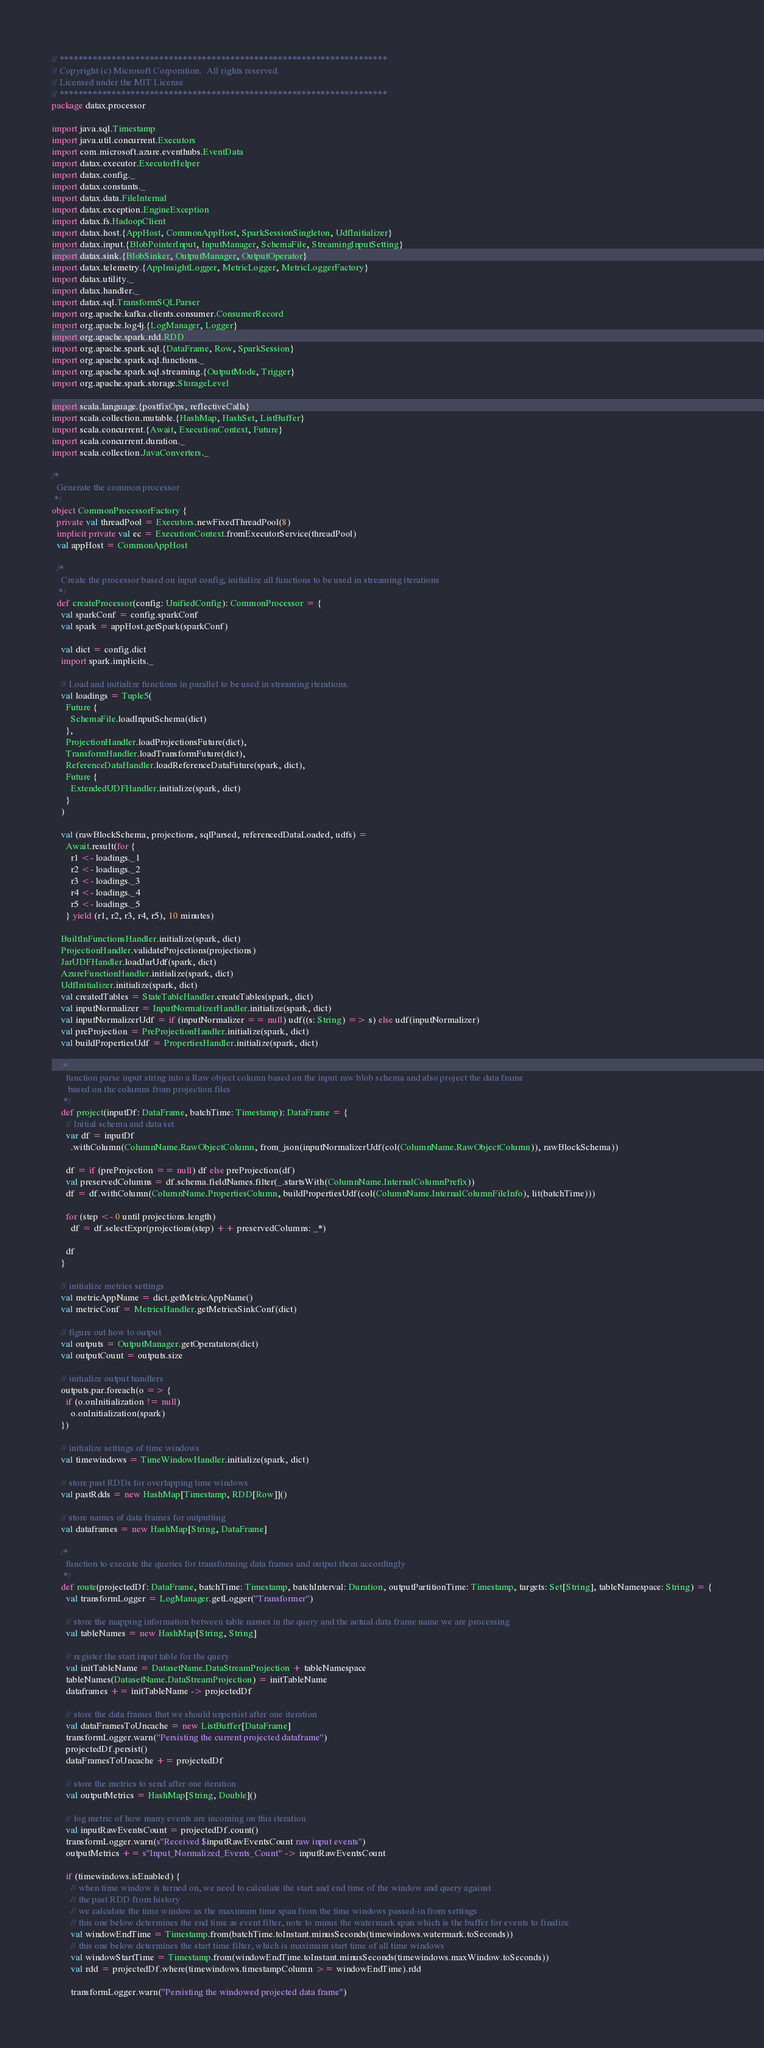Convert code to text. <code><loc_0><loc_0><loc_500><loc_500><_Scala_>// *********************************************************************
// Copyright (c) Microsoft Corporation.  All rights reserved.
// Licensed under the MIT License
// *********************************************************************
package datax.processor

import java.sql.Timestamp
import java.util.concurrent.Executors
import com.microsoft.azure.eventhubs.EventData
import datax.executor.ExecutorHelper
import datax.config._
import datax.constants._
import datax.data.FileInternal
import datax.exception.EngineException
import datax.fs.HadoopClient
import datax.host.{AppHost, CommonAppHost, SparkSessionSingleton, UdfInitializer}
import datax.input.{BlobPointerInput, InputManager, SchemaFile, StreamingInputSetting}
import datax.sink.{BlobSinker, OutputManager, OutputOperator}
import datax.telemetry.{AppInsightLogger, MetricLogger, MetricLoggerFactory}
import datax.utility._
import datax.handler._
import datax.sql.TransformSQLParser
import org.apache.kafka.clients.consumer.ConsumerRecord
import org.apache.log4j.{LogManager, Logger}
import org.apache.spark.rdd.RDD
import org.apache.spark.sql.{DataFrame, Row, SparkSession}
import org.apache.spark.sql.functions._
import org.apache.spark.sql.streaming.{OutputMode, Trigger}
import org.apache.spark.storage.StorageLevel

import scala.language.{postfixOps, reflectiveCalls}
import scala.collection.mutable.{HashMap, HashSet, ListBuffer}
import scala.concurrent.{Await, ExecutionContext, Future}
import scala.concurrent.duration._
import scala.collection.JavaConverters._

/*
  Generate the common processor
 */
object CommonProcessorFactory {
  private val threadPool = Executors.newFixedThreadPool(8)
  implicit private val ec = ExecutionContext.fromExecutorService(threadPool)
  val appHost = CommonAppHost

  /*
    Create the processor based on input config, initialize all functions to be used in streaming iterations
   */
  def createProcessor(config: UnifiedConfig): CommonProcessor = {
    val sparkConf = config.sparkConf
    val spark = appHost.getSpark(sparkConf)

    val dict = config.dict
    import spark.implicits._

    // Load and initialize functions in parallel to be used in streaming iterations.
    val loadings = Tuple5(
      Future {
        SchemaFile.loadInputSchema(dict)
      },
      ProjectionHandler.loadProjectionsFuture(dict),
      TransformHandler.loadTransformFuture(dict),
      ReferenceDataHandler.loadReferenceDataFuture(spark, dict),
      Future {
        ExtendedUDFHandler.initialize(spark, dict)
      }
    )

    val (rawBlockSchema, projections, sqlParsed, referencedDataLoaded, udfs) =
      Await.result(for {
        r1 <- loadings._1
        r2 <- loadings._2
        r3 <- loadings._3
        r4 <- loadings._4
        r5 <- loadings._5
      } yield (r1, r2, r3, r4, r5), 10 minutes)

    BuiltInFunctionsHandler.initialize(spark, dict)
    ProjectionHandler.validateProjections(projections)
    JarUDFHandler.loadJarUdf(spark, dict)
    AzureFunctionHandler.initialize(spark, dict)
    UdfInitializer.initialize(spark, dict)
    val createdTables = StateTableHandler.createTables(spark, dict)
    val inputNormalizer = InputNormalizerHandler.initialize(spark, dict)
    val inputNormalizerUdf = if (inputNormalizer == null) udf((s: String) => s) else udf(inputNormalizer)
    val preProjection = PreProjectionHandler.initialize(spark, dict)
    val buildPropertiesUdf = PropertiesHandler.initialize(spark, dict)

    /*
      function parse input string into a Raw object column based on the input raw blob schema and also project the data frame
       based on the columns from projection files
     */
    def project(inputDf: DataFrame, batchTime: Timestamp): DataFrame = {
      // Initial schema and data set
      var df = inputDf
        .withColumn(ColumnName.RawObjectColumn, from_json(inputNormalizerUdf(col(ColumnName.RawObjectColumn)), rawBlockSchema))

      df = if (preProjection == null) df else preProjection(df)
      val preservedColumns = df.schema.fieldNames.filter(_.startsWith(ColumnName.InternalColumnPrefix))
      df = df.withColumn(ColumnName.PropertiesColumn, buildPropertiesUdf(col(ColumnName.InternalColumnFileInfo), lit(batchTime)))

      for (step <- 0 until projections.length)
        df = df.selectExpr(projections(step) ++ preservedColumns: _*)

      df
    }

    // initialize metrics settings
    val metricAppName = dict.getMetricAppName()
    val metricConf = MetricsHandler.getMetricsSinkConf(dict)

    // figure out how to output
    val outputs = OutputManager.getOperatators(dict)
    val outputCount = outputs.size

    // initialize output handlers
    outputs.par.foreach(o => {
      if (o.onInitialization != null)
        o.onInitialization(spark)
    })

    // initialize settings of time windows
    val timewindows = TimeWindowHandler.initialize(spark, dict)

    // store past RDDs for overlapping time windows
    val pastRdds = new HashMap[Timestamp, RDD[Row]]()

    // store names of data frames for outputting
    val dataframes = new HashMap[String, DataFrame]

    /*
      function to execute the queries for transforming data frames and output them accordingly
     */
    def route(projectedDf: DataFrame, batchTime: Timestamp, batchInterval: Duration, outputPartitionTime: Timestamp, targets: Set[String], tableNamespace: String) = {
      val transformLogger = LogManager.getLogger("Transformer")

      // store the mapping information between table names in the query and the actual data frame name we are processing
      val tableNames = new HashMap[String, String]

      // register the start input table for the query
      val initTableName = DatasetName.DataStreamProjection + tableNamespace
      tableNames(DatasetName.DataStreamProjection) = initTableName
      dataframes += initTableName -> projectedDf

      // store the data frames that we should unpersist after one iteration
      val dataFramesToUncache = new ListBuffer[DataFrame]
      transformLogger.warn("Persisting the current projected dataframe")
      projectedDf.persist()
      dataFramesToUncache += projectedDf

      // store the metrics to send after one iteration
      val outputMetrics = HashMap[String, Double]()

      // log metric of how many events are incoming on this iteration
      val inputRawEventsCount = projectedDf.count()
      transformLogger.warn(s"Received $inputRawEventsCount raw input events")
      outputMetrics += s"Input_Normalized_Events_Count" -> inputRawEventsCount

      if (timewindows.isEnabled) {
        // when time window is turned on, we need to calculate the start and end time of the window and query against
        // the past RDD from history
        // we calculate the time window as the maximum time span from the time windows passed-in from settings
        // this one below determines the end time as event filter, note to minus the watermark span which is the buffer for events to finalize
        val windowEndTime = Timestamp.from(batchTime.toInstant.minusSeconds(timewindows.watermark.toSeconds))
        // this one below determines the start time filter, which is maximum start time of all time windows
        val windowStartTime = Timestamp.from(windowEndTime.toInstant.minusSeconds(timewindows.maxWindow.toSeconds))
        val rdd = projectedDf.where(timewindows.timestampColumn >= windowEndTime).rdd

        transformLogger.warn("Persisting the windowed projected data frame")</code> 